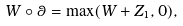Convert formula to latex. <formula><loc_0><loc_0><loc_500><loc_500>W \circ \theta = \max ( W + Z _ { 1 } , 0 ) ,</formula> 